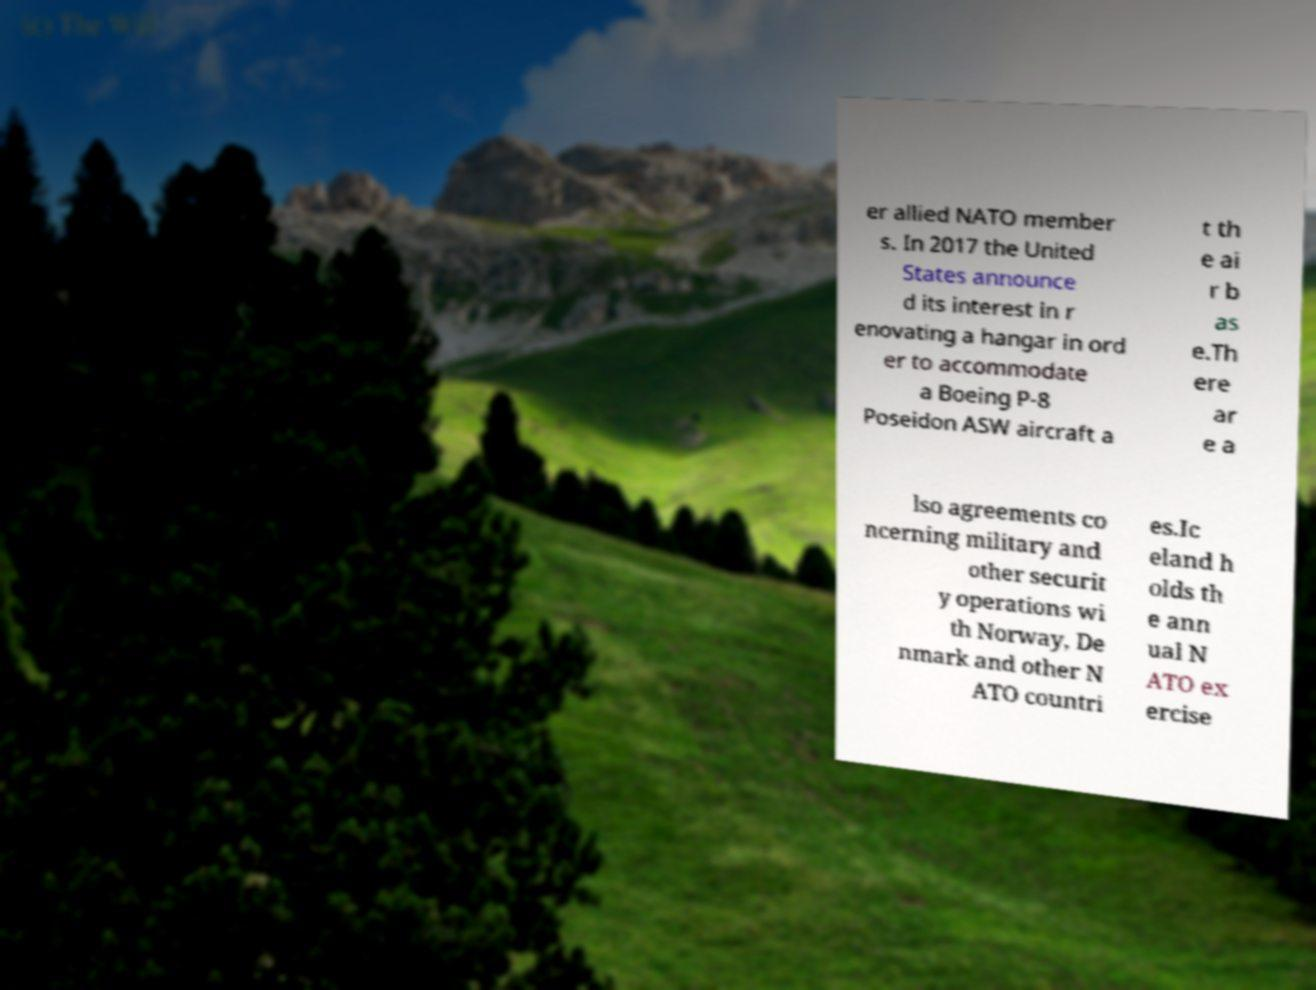There's text embedded in this image that I need extracted. Can you transcribe it verbatim? er allied NATO member s. In 2017 the United States announce d its interest in r enovating a hangar in ord er to accommodate a Boeing P-8 Poseidon ASW aircraft a t th e ai r b as e.Th ere ar e a lso agreements co ncerning military and other securit y operations wi th Norway, De nmark and other N ATO countri es.Ic eland h olds th e ann ual N ATO ex ercise 